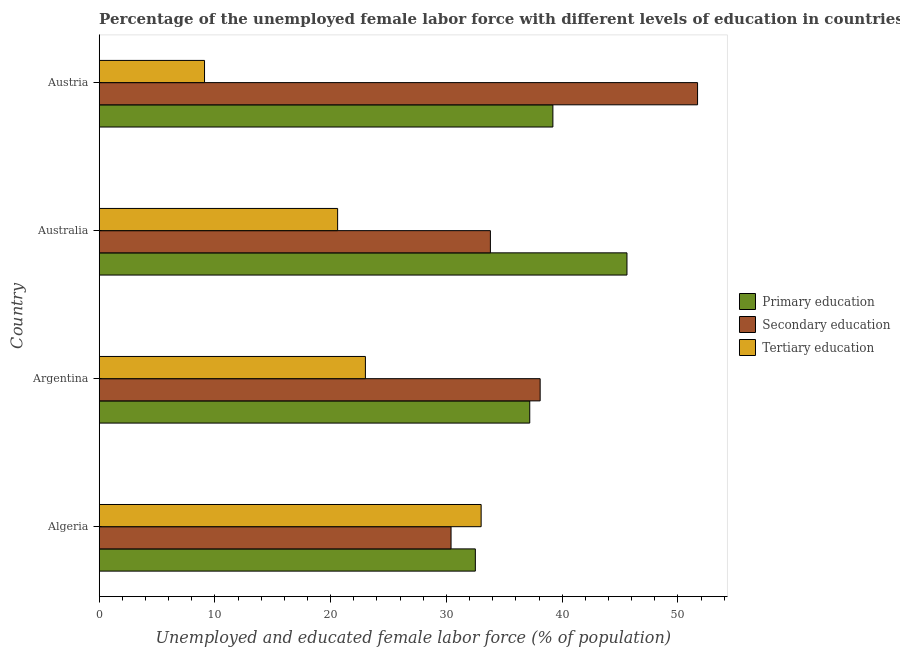Are the number of bars on each tick of the Y-axis equal?
Your response must be concise. Yes. How many bars are there on the 1st tick from the top?
Make the answer very short. 3. What is the label of the 3rd group of bars from the top?
Keep it short and to the point. Argentina. What is the percentage of female labor force who received primary education in Austria?
Offer a very short reply. 39.2. Across all countries, what is the minimum percentage of female labor force who received tertiary education?
Your answer should be compact. 9.1. In which country was the percentage of female labor force who received secondary education minimum?
Your answer should be compact. Algeria. What is the total percentage of female labor force who received tertiary education in the graph?
Your answer should be compact. 85.7. What is the difference between the percentage of female labor force who received secondary education in Algeria and that in Australia?
Make the answer very short. -3.4. What is the difference between the percentage of female labor force who received secondary education in Argentina and the percentage of female labor force who received tertiary education in Austria?
Provide a succinct answer. 29. What is the average percentage of female labor force who received primary education per country?
Your answer should be compact. 38.62. What is the difference between the percentage of female labor force who received primary education and percentage of female labor force who received tertiary education in Austria?
Your answer should be very brief. 30.1. In how many countries, is the percentage of female labor force who received primary education greater than 2 %?
Your answer should be very brief. 4. What is the ratio of the percentage of female labor force who received secondary education in Algeria to that in Australia?
Keep it short and to the point. 0.9. Is the percentage of female labor force who received primary education in Australia less than that in Austria?
Keep it short and to the point. No. What is the difference between the highest and the second highest percentage of female labor force who received primary education?
Offer a very short reply. 6.4. What is the difference between the highest and the lowest percentage of female labor force who received secondary education?
Offer a terse response. 21.3. In how many countries, is the percentage of female labor force who received primary education greater than the average percentage of female labor force who received primary education taken over all countries?
Make the answer very short. 2. Is the sum of the percentage of female labor force who received secondary education in Algeria and Argentina greater than the maximum percentage of female labor force who received primary education across all countries?
Keep it short and to the point. Yes. What does the 3rd bar from the bottom in Austria represents?
Your response must be concise. Tertiary education. Is it the case that in every country, the sum of the percentage of female labor force who received primary education and percentage of female labor force who received secondary education is greater than the percentage of female labor force who received tertiary education?
Your response must be concise. Yes. How many bars are there?
Ensure brevity in your answer.  12. Does the graph contain any zero values?
Make the answer very short. No. Does the graph contain grids?
Your answer should be very brief. No. How many legend labels are there?
Offer a terse response. 3. What is the title of the graph?
Your response must be concise. Percentage of the unemployed female labor force with different levels of education in countries. Does "Food" appear as one of the legend labels in the graph?
Give a very brief answer. No. What is the label or title of the X-axis?
Your answer should be very brief. Unemployed and educated female labor force (% of population). What is the label or title of the Y-axis?
Your answer should be compact. Country. What is the Unemployed and educated female labor force (% of population) in Primary education in Algeria?
Keep it short and to the point. 32.5. What is the Unemployed and educated female labor force (% of population) in Secondary education in Algeria?
Keep it short and to the point. 30.4. What is the Unemployed and educated female labor force (% of population) of Tertiary education in Algeria?
Keep it short and to the point. 33. What is the Unemployed and educated female labor force (% of population) in Primary education in Argentina?
Ensure brevity in your answer.  37.2. What is the Unemployed and educated female labor force (% of population) in Secondary education in Argentina?
Your answer should be compact. 38.1. What is the Unemployed and educated female labor force (% of population) of Primary education in Australia?
Your response must be concise. 45.6. What is the Unemployed and educated female labor force (% of population) of Secondary education in Australia?
Your answer should be very brief. 33.8. What is the Unemployed and educated female labor force (% of population) of Tertiary education in Australia?
Your answer should be very brief. 20.6. What is the Unemployed and educated female labor force (% of population) in Primary education in Austria?
Offer a very short reply. 39.2. What is the Unemployed and educated female labor force (% of population) of Secondary education in Austria?
Give a very brief answer. 51.7. What is the Unemployed and educated female labor force (% of population) of Tertiary education in Austria?
Your response must be concise. 9.1. Across all countries, what is the maximum Unemployed and educated female labor force (% of population) in Primary education?
Your answer should be very brief. 45.6. Across all countries, what is the maximum Unemployed and educated female labor force (% of population) in Secondary education?
Make the answer very short. 51.7. Across all countries, what is the minimum Unemployed and educated female labor force (% of population) of Primary education?
Provide a short and direct response. 32.5. Across all countries, what is the minimum Unemployed and educated female labor force (% of population) of Secondary education?
Offer a very short reply. 30.4. Across all countries, what is the minimum Unemployed and educated female labor force (% of population) of Tertiary education?
Ensure brevity in your answer.  9.1. What is the total Unemployed and educated female labor force (% of population) of Primary education in the graph?
Keep it short and to the point. 154.5. What is the total Unemployed and educated female labor force (% of population) of Secondary education in the graph?
Offer a terse response. 154. What is the total Unemployed and educated female labor force (% of population) of Tertiary education in the graph?
Offer a terse response. 85.7. What is the difference between the Unemployed and educated female labor force (% of population) of Primary education in Algeria and that in Argentina?
Offer a terse response. -4.7. What is the difference between the Unemployed and educated female labor force (% of population) in Secondary education in Algeria and that in Argentina?
Offer a very short reply. -7.7. What is the difference between the Unemployed and educated female labor force (% of population) of Primary education in Algeria and that in Australia?
Provide a succinct answer. -13.1. What is the difference between the Unemployed and educated female labor force (% of population) of Tertiary education in Algeria and that in Australia?
Keep it short and to the point. 12.4. What is the difference between the Unemployed and educated female labor force (% of population) in Secondary education in Algeria and that in Austria?
Offer a very short reply. -21.3. What is the difference between the Unemployed and educated female labor force (% of population) in Tertiary education in Algeria and that in Austria?
Offer a terse response. 23.9. What is the difference between the Unemployed and educated female labor force (% of population) of Tertiary education in Argentina and that in Austria?
Offer a very short reply. 13.9. What is the difference between the Unemployed and educated female labor force (% of population) of Primary education in Australia and that in Austria?
Ensure brevity in your answer.  6.4. What is the difference between the Unemployed and educated female labor force (% of population) of Secondary education in Australia and that in Austria?
Your answer should be compact. -17.9. What is the difference between the Unemployed and educated female labor force (% of population) in Primary education in Algeria and the Unemployed and educated female labor force (% of population) in Tertiary education in Argentina?
Provide a short and direct response. 9.5. What is the difference between the Unemployed and educated female labor force (% of population) of Secondary education in Algeria and the Unemployed and educated female labor force (% of population) of Tertiary education in Argentina?
Offer a terse response. 7.4. What is the difference between the Unemployed and educated female labor force (% of population) of Primary education in Algeria and the Unemployed and educated female labor force (% of population) of Secondary education in Austria?
Keep it short and to the point. -19.2. What is the difference between the Unemployed and educated female labor force (% of population) in Primary education in Algeria and the Unemployed and educated female labor force (% of population) in Tertiary education in Austria?
Offer a terse response. 23.4. What is the difference between the Unemployed and educated female labor force (% of population) of Secondary education in Algeria and the Unemployed and educated female labor force (% of population) of Tertiary education in Austria?
Your answer should be very brief. 21.3. What is the difference between the Unemployed and educated female labor force (% of population) in Primary education in Argentina and the Unemployed and educated female labor force (% of population) in Tertiary education in Austria?
Provide a short and direct response. 28.1. What is the difference between the Unemployed and educated female labor force (% of population) of Primary education in Australia and the Unemployed and educated female labor force (% of population) of Secondary education in Austria?
Make the answer very short. -6.1. What is the difference between the Unemployed and educated female labor force (% of population) of Primary education in Australia and the Unemployed and educated female labor force (% of population) of Tertiary education in Austria?
Give a very brief answer. 36.5. What is the difference between the Unemployed and educated female labor force (% of population) in Secondary education in Australia and the Unemployed and educated female labor force (% of population) in Tertiary education in Austria?
Your answer should be very brief. 24.7. What is the average Unemployed and educated female labor force (% of population) of Primary education per country?
Give a very brief answer. 38.62. What is the average Unemployed and educated female labor force (% of population) of Secondary education per country?
Your answer should be compact. 38.5. What is the average Unemployed and educated female labor force (% of population) in Tertiary education per country?
Make the answer very short. 21.43. What is the difference between the Unemployed and educated female labor force (% of population) in Primary education and Unemployed and educated female labor force (% of population) in Secondary education in Algeria?
Your answer should be very brief. 2.1. What is the difference between the Unemployed and educated female labor force (% of population) of Primary education and Unemployed and educated female labor force (% of population) of Tertiary education in Argentina?
Give a very brief answer. 14.2. What is the difference between the Unemployed and educated female labor force (% of population) in Secondary education and Unemployed and educated female labor force (% of population) in Tertiary education in Argentina?
Your response must be concise. 15.1. What is the difference between the Unemployed and educated female labor force (% of population) in Primary education and Unemployed and educated female labor force (% of population) in Tertiary education in Austria?
Ensure brevity in your answer.  30.1. What is the difference between the Unemployed and educated female labor force (% of population) in Secondary education and Unemployed and educated female labor force (% of population) in Tertiary education in Austria?
Give a very brief answer. 42.6. What is the ratio of the Unemployed and educated female labor force (% of population) of Primary education in Algeria to that in Argentina?
Your answer should be very brief. 0.87. What is the ratio of the Unemployed and educated female labor force (% of population) of Secondary education in Algeria to that in Argentina?
Make the answer very short. 0.8. What is the ratio of the Unemployed and educated female labor force (% of population) in Tertiary education in Algeria to that in Argentina?
Your answer should be very brief. 1.43. What is the ratio of the Unemployed and educated female labor force (% of population) in Primary education in Algeria to that in Australia?
Offer a very short reply. 0.71. What is the ratio of the Unemployed and educated female labor force (% of population) of Secondary education in Algeria to that in Australia?
Offer a terse response. 0.9. What is the ratio of the Unemployed and educated female labor force (% of population) of Tertiary education in Algeria to that in Australia?
Offer a terse response. 1.6. What is the ratio of the Unemployed and educated female labor force (% of population) of Primary education in Algeria to that in Austria?
Your answer should be compact. 0.83. What is the ratio of the Unemployed and educated female labor force (% of population) of Secondary education in Algeria to that in Austria?
Offer a terse response. 0.59. What is the ratio of the Unemployed and educated female labor force (% of population) of Tertiary education in Algeria to that in Austria?
Offer a terse response. 3.63. What is the ratio of the Unemployed and educated female labor force (% of population) in Primary education in Argentina to that in Australia?
Offer a very short reply. 0.82. What is the ratio of the Unemployed and educated female labor force (% of population) in Secondary education in Argentina to that in Australia?
Your response must be concise. 1.13. What is the ratio of the Unemployed and educated female labor force (% of population) of Tertiary education in Argentina to that in Australia?
Your answer should be very brief. 1.12. What is the ratio of the Unemployed and educated female labor force (% of population) of Primary education in Argentina to that in Austria?
Make the answer very short. 0.95. What is the ratio of the Unemployed and educated female labor force (% of population) in Secondary education in Argentina to that in Austria?
Your response must be concise. 0.74. What is the ratio of the Unemployed and educated female labor force (% of population) of Tertiary education in Argentina to that in Austria?
Offer a very short reply. 2.53. What is the ratio of the Unemployed and educated female labor force (% of population) of Primary education in Australia to that in Austria?
Ensure brevity in your answer.  1.16. What is the ratio of the Unemployed and educated female labor force (% of population) of Secondary education in Australia to that in Austria?
Your response must be concise. 0.65. What is the ratio of the Unemployed and educated female labor force (% of population) of Tertiary education in Australia to that in Austria?
Provide a succinct answer. 2.26. What is the difference between the highest and the second highest Unemployed and educated female labor force (% of population) of Secondary education?
Ensure brevity in your answer.  13.6. What is the difference between the highest and the lowest Unemployed and educated female labor force (% of population) of Primary education?
Your response must be concise. 13.1. What is the difference between the highest and the lowest Unemployed and educated female labor force (% of population) in Secondary education?
Your answer should be very brief. 21.3. What is the difference between the highest and the lowest Unemployed and educated female labor force (% of population) of Tertiary education?
Provide a short and direct response. 23.9. 